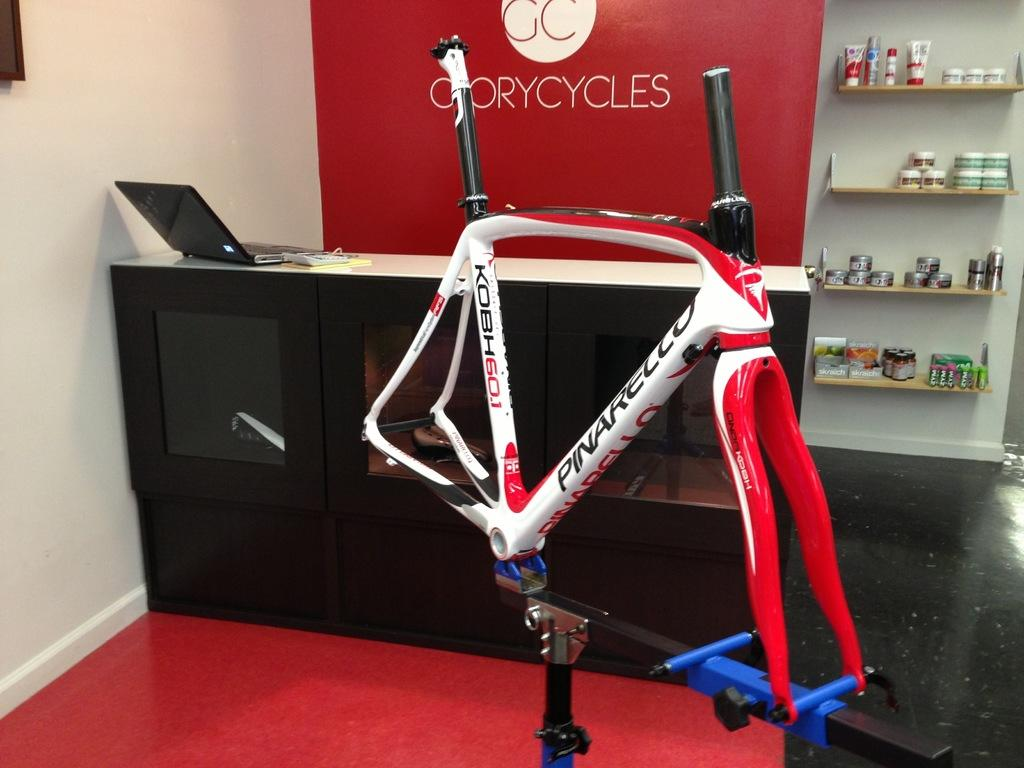<image>
Write a terse but informative summary of the picture. A bicycle frame sits in front of a desk for GloryCycles. 